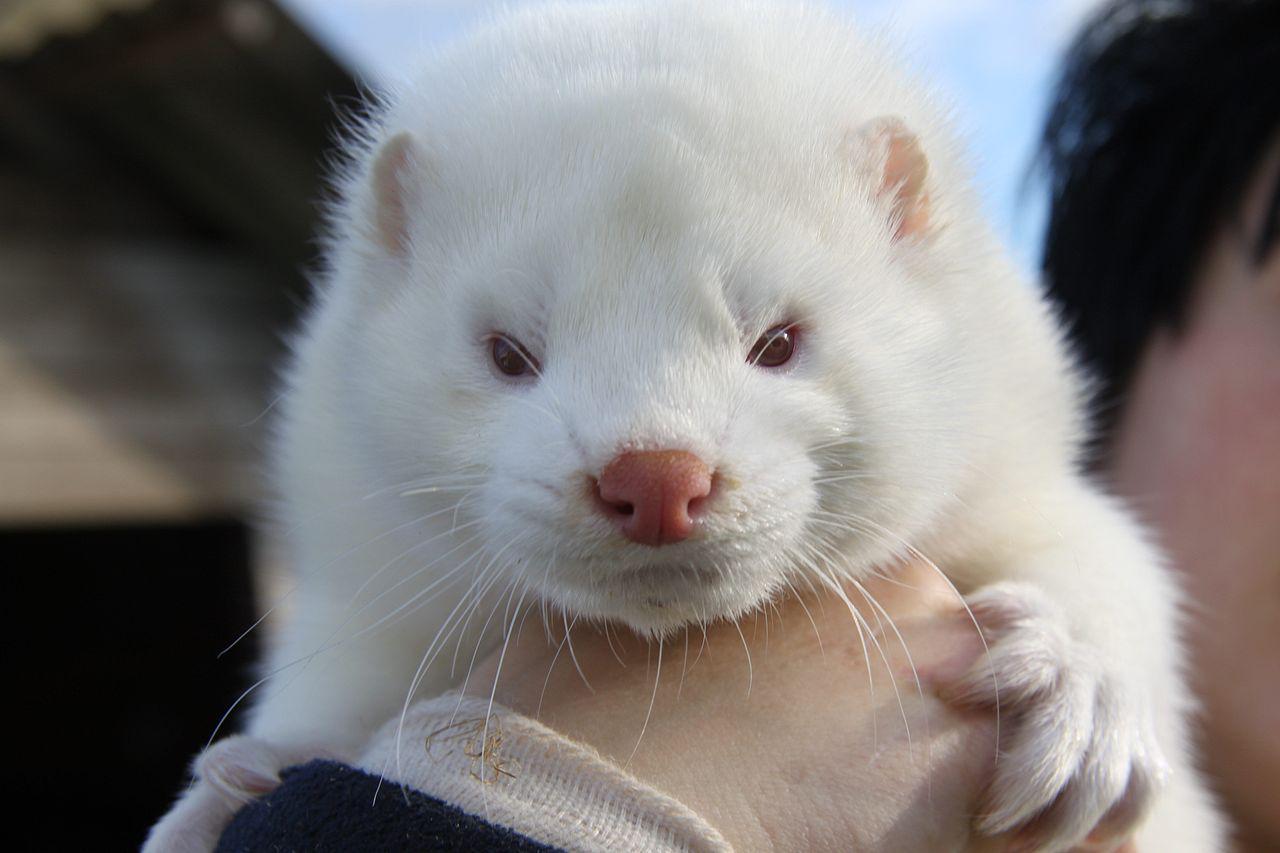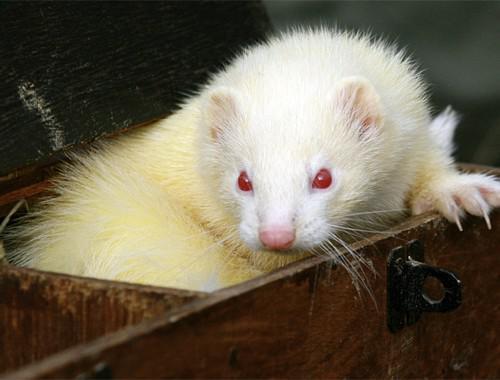The first image is the image on the left, the second image is the image on the right. Analyze the images presented: Is the assertion "A person is holding up the animal in one of the images." valid? Answer yes or no. Yes. The first image is the image on the left, the second image is the image on the right. Considering the images on both sides, is "a white ferret is being held in a human hand" valid? Answer yes or no. Yes. 